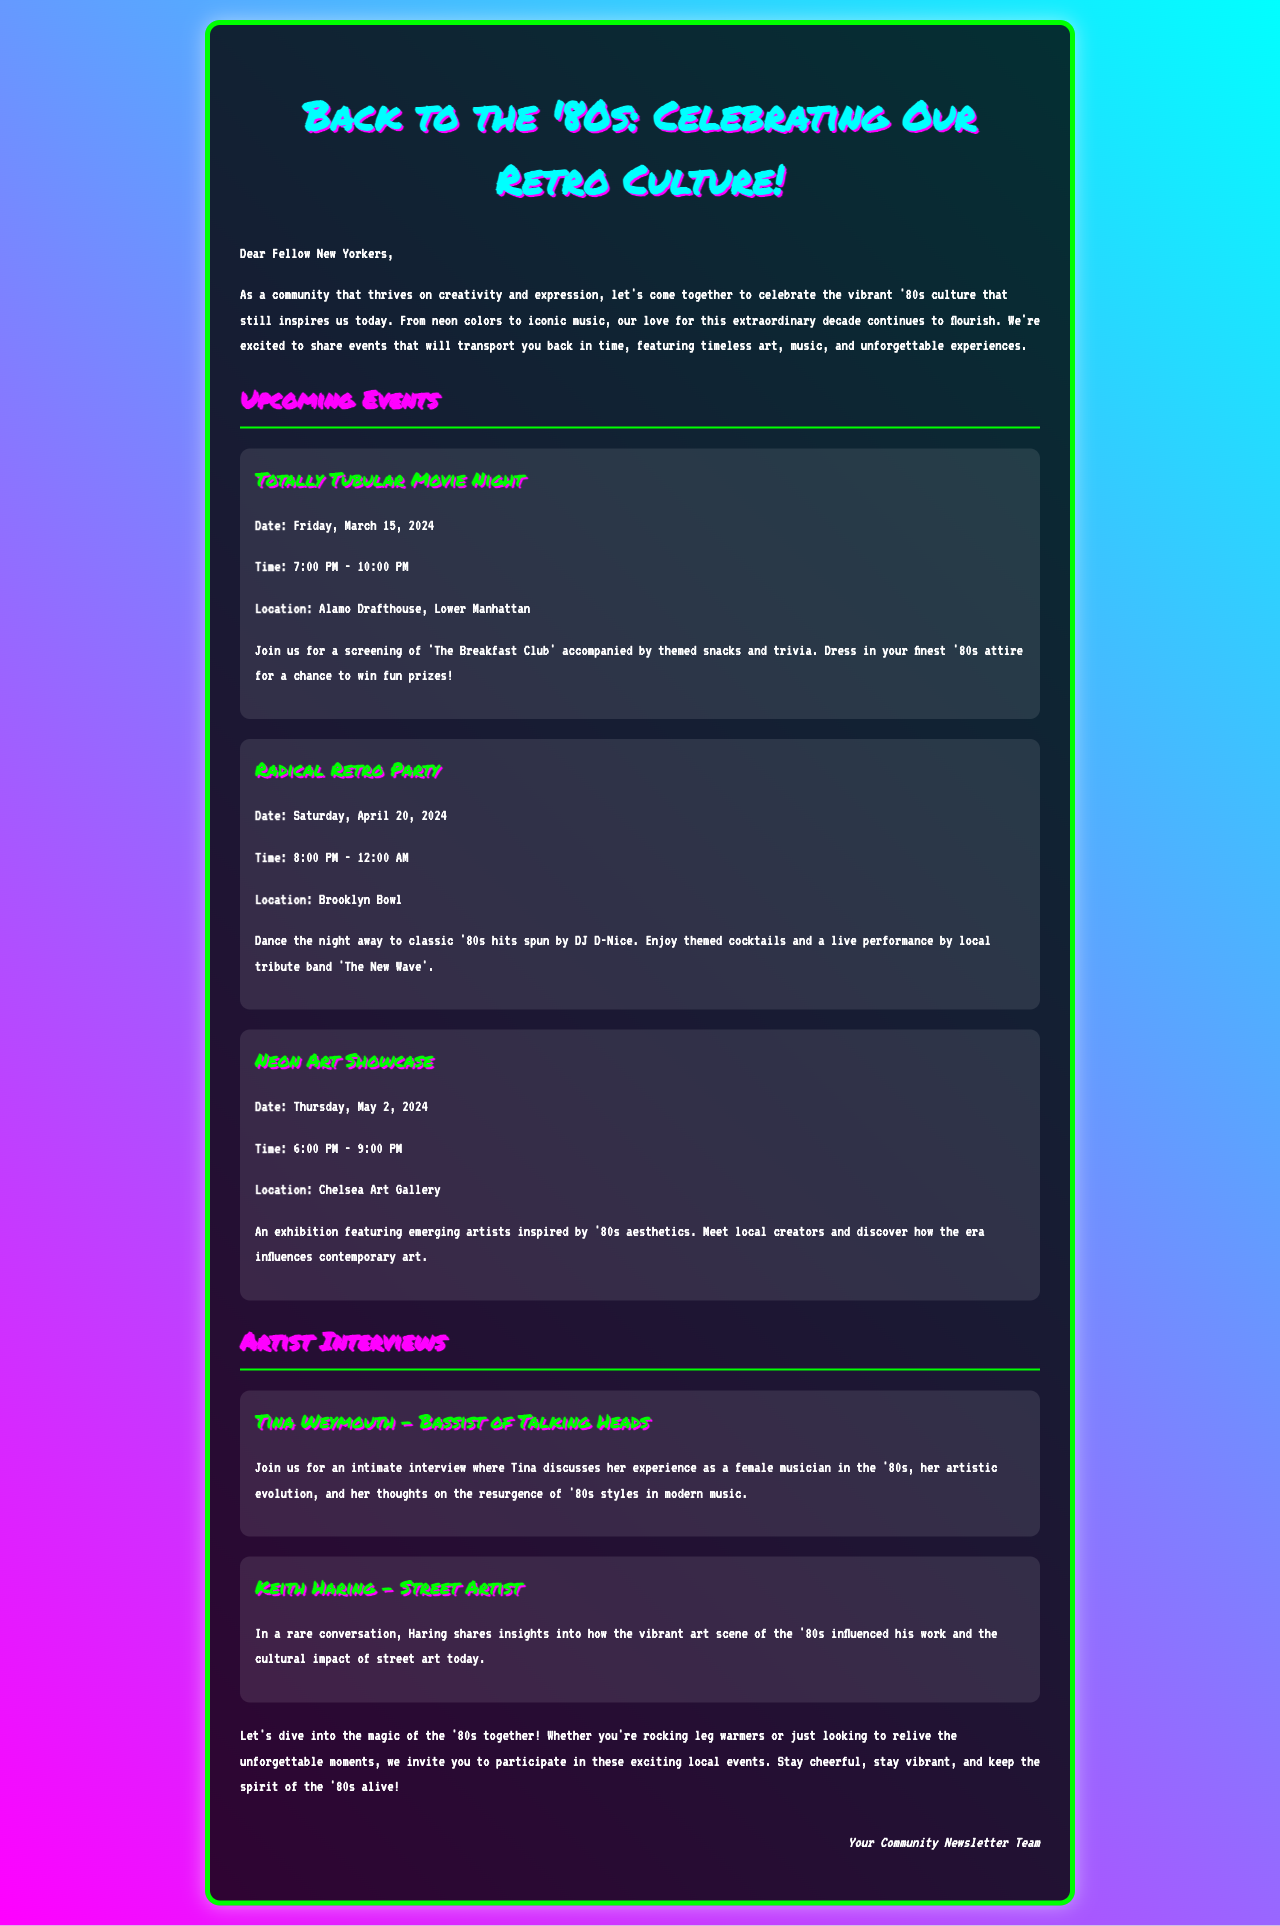what is the title of the newsletter? The title is stated prominently at the top of the document.
Answer: Back to the '80s: Celebrating Our Retro Culture! what is the date of the Totally Tubular Movie Night? The date is mentioned in the event details section of the newsletter.
Answer: Friday, March 15, 2024 where will the Radical Retro Party be held? The location is specified within the event details of the Radical Retro Party.
Answer: Brooklyn Bowl who is being interviewed in the newsletter? The document lists the names of the artists featured in the interviews section.
Answer: Tina Weymouth, Keith Haring what time does the Neon Art Showcase start? The start time is provided in the event details section under Neon Art Showcase.
Answer: 6:00 PM how long will the Radical Retro Party last? The duration is provided in the event details of the Radical Retro Party.
Answer: 4 hours what type of event is the Totally Tubular Movie Night? The type of event is described in the details provided for the movie night.
Answer: Movie Screening what theme is referenced in the upcoming events? The theme is consistently highlighted throughout the events portion of the newsletter.
Answer: '80s culture what is the name of the band performing at the Radical Retro Party? The document states the name of the band in the description of the event.
Answer: The New Wave 